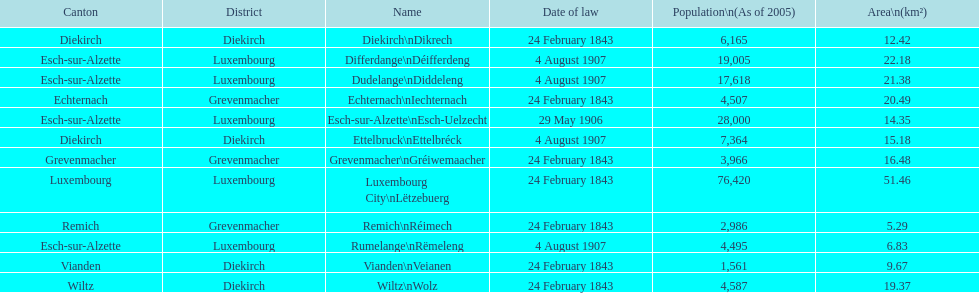Could you parse the entire table as a dict? {'header': ['Canton', 'District', 'Name', 'Date of law', 'Population\\n(As of 2005)', 'Area\\n(km²)'], 'rows': [['Diekirch', 'Diekirch', 'Diekirch\\nDikrech', '24 February 1843', '6,165', '12.42'], ['Esch-sur-Alzette', 'Luxembourg', 'Differdange\\nDéifferdeng', '4 August 1907', '19,005', '22.18'], ['Esch-sur-Alzette', 'Luxembourg', 'Dudelange\\nDiddeleng', '4 August 1907', '17,618', '21.38'], ['Echternach', 'Grevenmacher', 'Echternach\\nIechternach', '24 February 1843', '4,507', '20.49'], ['Esch-sur-Alzette', 'Luxembourg', 'Esch-sur-Alzette\\nEsch-Uelzecht', '29 May 1906', '28,000', '14.35'], ['Diekirch', 'Diekirch', 'Ettelbruck\\nEttelbréck', '4 August 1907', '7,364', '15.18'], ['Grevenmacher', 'Grevenmacher', 'Grevenmacher\\nGréiwemaacher', '24 February 1843', '3,966', '16.48'], ['Luxembourg', 'Luxembourg', 'Luxembourg City\\nLëtzebuerg', '24 February 1843', '76,420', '51.46'], ['Remich', 'Grevenmacher', 'Remich\\nRéimech', '24 February 1843', '2,986', '5.29'], ['Esch-sur-Alzette', 'Luxembourg', 'Rumelange\\nRëmeleng', '4 August 1907', '4,495', '6.83'], ['Vianden', 'Diekirch', 'Vianden\\nVeianen', '24 February 1843', '1,561', '9.67'], ['Wiltz', 'Diekirch', 'Wiltz\\nWolz', '24 February 1843', '4,587', '19.37']]} What canton is the most populated? Luxembourg. 